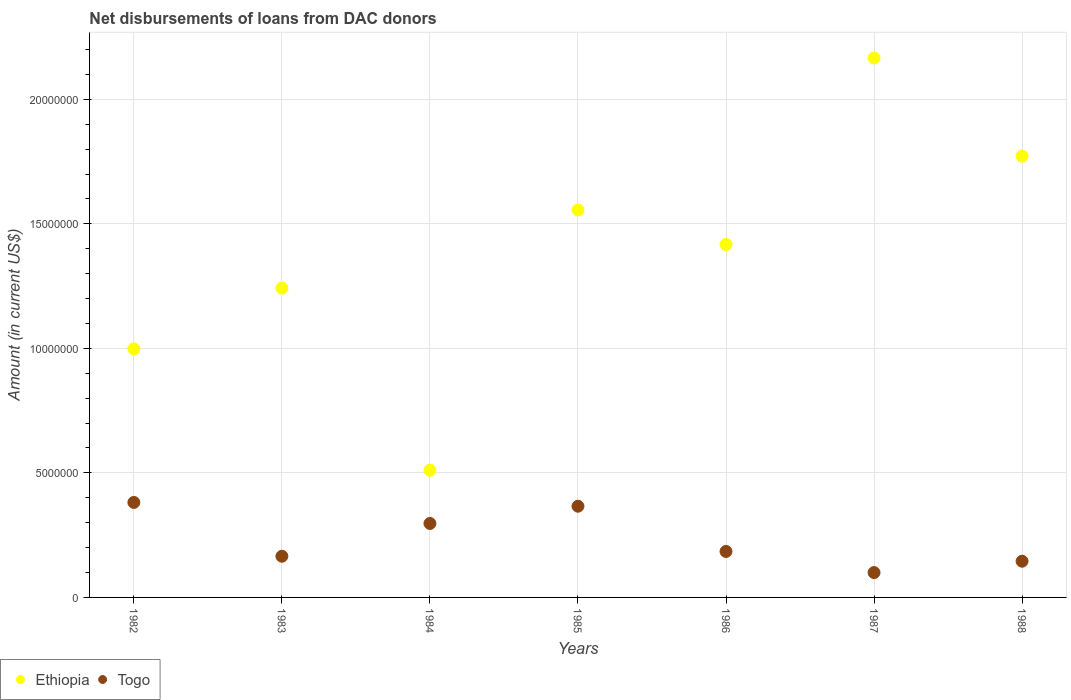Is the number of dotlines equal to the number of legend labels?
Offer a very short reply. Yes. What is the amount of loans disbursed in Ethiopia in 1987?
Keep it short and to the point. 2.17e+07. Across all years, what is the maximum amount of loans disbursed in Ethiopia?
Provide a succinct answer. 2.17e+07. Across all years, what is the minimum amount of loans disbursed in Togo?
Ensure brevity in your answer.  9.98e+05. In which year was the amount of loans disbursed in Togo maximum?
Ensure brevity in your answer.  1982. What is the total amount of loans disbursed in Togo in the graph?
Keep it short and to the point. 1.64e+07. What is the difference between the amount of loans disbursed in Togo in 1985 and that in 1988?
Give a very brief answer. 2.21e+06. What is the difference between the amount of loans disbursed in Ethiopia in 1985 and the amount of loans disbursed in Togo in 1982?
Make the answer very short. 1.17e+07. What is the average amount of loans disbursed in Ethiopia per year?
Give a very brief answer. 1.38e+07. In the year 1988, what is the difference between the amount of loans disbursed in Togo and amount of loans disbursed in Ethiopia?
Keep it short and to the point. -1.63e+07. What is the ratio of the amount of loans disbursed in Togo in 1983 to that in 1985?
Your answer should be compact. 0.45. Is the amount of loans disbursed in Togo in 1985 less than that in 1986?
Your answer should be very brief. No. Is the difference between the amount of loans disbursed in Togo in 1982 and 1984 greater than the difference between the amount of loans disbursed in Ethiopia in 1982 and 1984?
Your answer should be very brief. No. What is the difference between the highest and the second highest amount of loans disbursed in Togo?
Your answer should be very brief. 1.52e+05. What is the difference between the highest and the lowest amount of loans disbursed in Togo?
Offer a very short reply. 2.82e+06. In how many years, is the amount of loans disbursed in Togo greater than the average amount of loans disbursed in Togo taken over all years?
Your response must be concise. 3. Does the amount of loans disbursed in Togo monotonically increase over the years?
Your answer should be compact. No. Is the amount of loans disbursed in Ethiopia strictly greater than the amount of loans disbursed in Togo over the years?
Make the answer very short. Yes. Is the amount of loans disbursed in Togo strictly less than the amount of loans disbursed in Ethiopia over the years?
Ensure brevity in your answer.  Yes. How many dotlines are there?
Your answer should be very brief. 2. What is the difference between two consecutive major ticks on the Y-axis?
Keep it short and to the point. 5.00e+06. Are the values on the major ticks of Y-axis written in scientific E-notation?
Provide a succinct answer. No. Does the graph contain grids?
Provide a short and direct response. Yes. Where does the legend appear in the graph?
Your answer should be compact. Bottom left. How many legend labels are there?
Your response must be concise. 2. How are the legend labels stacked?
Offer a very short reply. Horizontal. What is the title of the graph?
Make the answer very short. Net disbursements of loans from DAC donors. What is the Amount (in current US$) of Ethiopia in 1982?
Your response must be concise. 9.98e+06. What is the Amount (in current US$) in Togo in 1982?
Your response must be concise. 3.81e+06. What is the Amount (in current US$) of Ethiopia in 1983?
Keep it short and to the point. 1.24e+07. What is the Amount (in current US$) of Togo in 1983?
Give a very brief answer. 1.65e+06. What is the Amount (in current US$) in Ethiopia in 1984?
Provide a short and direct response. 5.11e+06. What is the Amount (in current US$) of Togo in 1984?
Your answer should be compact. 2.97e+06. What is the Amount (in current US$) in Ethiopia in 1985?
Your response must be concise. 1.56e+07. What is the Amount (in current US$) of Togo in 1985?
Offer a very short reply. 3.66e+06. What is the Amount (in current US$) in Ethiopia in 1986?
Keep it short and to the point. 1.42e+07. What is the Amount (in current US$) in Togo in 1986?
Offer a very short reply. 1.85e+06. What is the Amount (in current US$) in Ethiopia in 1987?
Provide a short and direct response. 2.17e+07. What is the Amount (in current US$) in Togo in 1987?
Offer a very short reply. 9.98e+05. What is the Amount (in current US$) of Ethiopia in 1988?
Your answer should be very brief. 1.77e+07. What is the Amount (in current US$) in Togo in 1988?
Provide a succinct answer. 1.45e+06. Across all years, what is the maximum Amount (in current US$) in Ethiopia?
Offer a very short reply. 2.17e+07. Across all years, what is the maximum Amount (in current US$) of Togo?
Your response must be concise. 3.81e+06. Across all years, what is the minimum Amount (in current US$) of Ethiopia?
Keep it short and to the point. 5.11e+06. Across all years, what is the minimum Amount (in current US$) in Togo?
Offer a very short reply. 9.98e+05. What is the total Amount (in current US$) in Ethiopia in the graph?
Ensure brevity in your answer.  9.66e+07. What is the total Amount (in current US$) in Togo in the graph?
Keep it short and to the point. 1.64e+07. What is the difference between the Amount (in current US$) of Ethiopia in 1982 and that in 1983?
Your response must be concise. -2.44e+06. What is the difference between the Amount (in current US$) in Togo in 1982 and that in 1983?
Give a very brief answer. 2.16e+06. What is the difference between the Amount (in current US$) in Ethiopia in 1982 and that in 1984?
Provide a short and direct response. 4.87e+06. What is the difference between the Amount (in current US$) in Togo in 1982 and that in 1984?
Make the answer very short. 8.44e+05. What is the difference between the Amount (in current US$) of Ethiopia in 1982 and that in 1985?
Provide a short and direct response. -5.58e+06. What is the difference between the Amount (in current US$) in Togo in 1982 and that in 1985?
Provide a short and direct response. 1.52e+05. What is the difference between the Amount (in current US$) in Ethiopia in 1982 and that in 1986?
Keep it short and to the point. -4.19e+06. What is the difference between the Amount (in current US$) of Togo in 1982 and that in 1986?
Offer a very short reply. 1.97e+06. What is the difference between the Amount (in current US$) in Ethiopia in 1982 and that in 1987?
Give a very brief answer. -1.17e+07. What is the difference between the Amount (in current US$) in Togo in 1982 and that in 1987?
Offer a very short reply. 2.82e+06. What is the difference between the Amount (in current US$) of Ethiopia in 1982 and that in 1988?
Provide a short and direct response. -7.74e+06. What is the difference between the Amount (in current US$) of Togo in 1982 and that in 1988?
Keep it short and to the point. 2.36e+06. What is the difference between the Amount (in current US$) in Ethiopia in 1983 and that in 1984?
Ensure brevity in your answer.  7.31e+06. What is the difference between the Amount (in current US$) of Togo in 1983 and that in 1984?
Keep it short and to the point. -1.32e+06. What is the difference between the Amount (in current US$) of Ethiopia in 1983 and that in 1985?
Give a very brief answer. -3.14e+06. What is the difference between the Amount (in current US$) of Togo in 1983 and that in 1985?
Offer a very short reply. -2.01e+06. What is the difference between the Amount (in current US$) in Ethiopia in 1983 and that in 1986?
Provide a succinct answer. -1.75e+06. What is the difference between the Amount (in current US$) of Togo in 1983 and that in 1986?
Give a very brief answer. -1.93e+05. What is the difference between the Amount (in current US$) in Ethiopia in 1983 and that in 1987?
Provide a short and direct response. -9.24e+06. What is the difference between the Amount (in current US$) of Togo in 1983 and that in 1987?
Your response must be concise. 6.55e+05. What is the difference between the Amount (in current US$) of Ethiopia in 1983 and that in 1988?
Provide a short and direct response. -5.30e+06. What is the difference between the Amount (in current US$) of Togo in 1983 and that in 1988?
Offer a very short reply. 1.99e+05. What is the difference between the Amount (in current US$) in Ethiopia in 1984 and that in 1985?
Ensure brevity in your answer.  -1.04e+07. What is the difference between the Amount (in current US$) in Togo in 1984 and that in 1985?
Provide a short and direct response. -6.92e+05. What is the difference between the Amount (in current US$) in Ethiopia in 1984 and that in 1986?
Your response must be concise. -9.06e+06. What is the difference between the Amount (in current US$) of Togo in 1984 and that in 1986?
Ensure brevity in your answer.  1.12e+06. What is the difference between the Amount (in current US$) of Ethiopia in 1984 and that in 1987?
Keep it short and to the point. -1.66e+07. What is the difference between the Amount (in current US$) of Togo in 1984 and that in 1987?
Give a very brief answer. 1.97e+06. What is the difference between the Amount (in current US$) of Ethiopia in 1984 and that in 1988?
Offer a very short reply. -1.26e+07. What is the difference between the Amount (in current US$) of Togo in 1984 and that in 1988?
Your answer should be compact. 1.52e+06. What is the difference between the Amount (in current US$) in Ethiopia in 1985 and that in 1986?
Offer a terse response. 1.39e+06. What is the difference between the Amount (in current US$) of Togo in 1985 and that in 1986?
Provide a short and direct response. 1.82e+06. What is the difference between the Amount (in current US$) in Ethiopia in 1985 and that in 1987?
Keep it short and to the point. -6.10e+06. What is the difference between the Amount (in current US$) in Togo in 1985 and that in 1987?
Offer a very short reply. 2.66e+06. What is the difference between the Amount (in current US$) of Ethiopia in 1985 and that in 1988?
Offer a terse response. -2.16e+06. What is the difference between the Amount (in current US$) of Togo in 1985 and that in 1988?
Keep it short and to the point. 2.21e+06. What is the difference between the Amount (in current US$) of Ethiopia in 1986 and that in 1987?
Make the answer very short. -7.49e+06. What is the difference between the Amount (in current US$) in Togo in 1986 and that in 1987?
Make the answer very short. 8.48e+05. What is the difference between the Amount (in current US$) of Ethiopia in 1986 and that in 1988?
Give a very brief answer. -3.55e+06. What is the difference between the Amount (in current US$) in Togo in 1986 and that in 1988?
Your answer should be very brief. 3.92e+05. What is the difference between the Amount (in current US$) of Ethiopia in 1987 and that in 1988?
Provide a short and direct response. 3.94e+06. What is the difference between the Amount (in current US$) in Togo in 1987 and that in 1988?
Offer a terse response. -4.56e+05. What is the difference between the Amount (in current US$) of Ethiopia in 1982 and the Amount (in current US$) of Togo in 1983?
Your answer should be compact. 8.33e+06. What is the difference between the Amount (in current US$) of Ethiopia in 1982 and the Amount (in current US$) of Togo in 1984?
Offer a terse response. 7.01e+06. What is the difference between the Amount (in current US$) of Ethiopia in 1982 and the Amount (in current US$) of Togo in 1985?
Provide a succinct answer. 6.32e+06. What is the difference between the Amount (in current US$) of Ethiopia in 1982 and the Amount (in current US$) of Togo in 1986?
Offer a very short reply. 8.13e+06. What is the difference between the Amount (in current US$) of Ethiopia in 1982 and the Amount (in current US$) of Togo in 1987?
Your response must be concise. 8.98e+06. What is the difference between the Amount (in current US$) of Ethiopia in 1982 and the Amount (in current US$) of Togo in 1988?
Keep it short and to the point. 8.52e+06. What is the difference between the Amount (in current US$) of Ethiopia in 1983 and the Amount (in current US$) of Togo in 1984?
Provide a succinct answer. 9.45e+06. What is the difference between the Amount (in current US$) of Ethiopia in 1983 and the Amount (in current US$) of Togo in 1985?
Make the answer very short. 8.76e+06. What is the difference between the Amount (in current US$) in Ethiopia in 1983 and the Amount (in current US$) in Togo in 1986?
Ensure brevity in your answer.  1.06e+07. What is the difference between the Amount (in current US$) in Ethiopia in 1983 and the Amount (in current US$) in Togo in 1987?
Provide a short and direct response. 1.14e+07. What is the difference between the Amount (in current US$) in Ethiopia in 1983 and the Amount (in current US$) in Togo in 1988?
Ensure brevity in your answer.  1.10e+07. What is the difference between the Amount (in current US$) of Ethiopia in 1984 and the Amount (in current US$) of Togo in 1985?
Keep it short and to the point. 1.45e+06. What is the difference between the Amount (in current US$) in Ethiopia in 1984 and the Amount (in current US$) in Togo in 1986?
Your answer should be compact. 3.26e+06. What is the difference between the Amount (in current US$) of Ethiopia in 1984 and the Amount (in current US$) of Togo in 1987?
Provide a succinct answer. 4.11e+06. What is the difference between the Amount (in current US$) of Ethiopia in 1984 and the Amount (in current US$) of Togo in 1988?
Provide a succinct answer. 3.66e+06. What is the difference between the Amount (in current US$) of Ethiopia in 1985 and the Amount (in current US$) of Togo in 1986?
Ensure brevity in your answer.  1.37e+07. What is the difference between the Amount (in current US$) of Ethiopia in 1985 and the Amount (in current US$) of Togo in 1987?
Provide a succinct answer. 1.46e+07. What is the difference between the Amount (in current US$) in Ethiopia in 1985 and the Amount (in current US$) in Togo in 1988?
Ensure brevity in your answer.  1.41e+07. What is the difference between the Amount (in current US$) of Ethiopia in 1986 and the Amount (in current US$) of Togo in 1987?
Your response must be concise. 1.32e+07. What is the difference between the Amount (in current US$) of Ethiopia in 1986 and the Amount (in current US$) of Togo in 1988?
Your answer should be very brief. 1.27e+07. What is the difference between the Amount (in current US$) in Ethiopia in 1987 and the Amount (in current US$) in Togo in 1988?
Your answer should be compact. 2.02e+07. What is the average Amount (in current US$) in Ethiopia per year?
Keep it short and to the point. 1.38e+07. What is the average Amount (in current US$) of Togo per year?
Provide a succinct answer. 2.34e+06. In the year 1982, what is the difference between the Amount (in current US$) of Ethiopia and Amount (in current US$) of Togo?
Make the answer very short. 6.16e+06. In the year 1983, what is the difference between the Amount (in current US$) of Ethiopia and Amount (in current US$) of Togo?
Provide a succinct answer. 1.08e+07. In the year 1984, what is the difference between the Amount (in current US$) in Ethiopia and Amount (in current US$) in Togo?
Offer a terse response. 2.14e+06. In the year 1985, what is the difference between the Amount (in current US$) of Ethiopia and Amount (in current US$) of Togo?
Your answer should be compact. 1.19e+07. In the year 1986, what is the difference between the Amount (in current US$) in Ethiopia and Amount (in current US$) in Togo?
Your answer should be very brief. 1.23e+07. In the year 1987, what is the difference between the Amount (in current US$) of Ethiopia and Amount (in current US$) of Togo?
Provide a succinct answer. 2.07e+07. In the year 1988, what is the difference between the Amount (in current US$) of Ethiopia and Amount (in current US$) of Togo?
Ensure brevity in your answer.  1.63e+07. What is the ratio of the Amount (in current US$) in Ethiopia in 1982 to that in 1983?
Your answer should be compact. 0.8. What is the ratio of the Amount (in current US$) in Togo in 1982 to that in 1983?
Provide a short and direct response. 2.31. What is the ratio of the Amount (in current US$) of Ethiopia in 1982 to that in 1984?
Give a very brief answer. 1.95. What is the ratio of the Amount (in current US$) in Togo in 1982 to that in 1984?
Offer a terse response. 1.28. What is the ratio of the Amount (in current US$) of Ethiopia in 1982 to that in 1985?
Provide a short and direct response. 0.64. What is the ratio of the Amount (in current US$) in Togo in 1982 to that in 1985?
Ensure brevity in your answer.  1.04. What is the ratio of the Amount (in current US$) in Ethiopia in 1982 to that in 1986?
Your answer should be compact. 0.7. What is the ratio of the Amount (in current US$) in Togo in 1982 to that in 1986?
Make the answer very short. 2.07. What is the ratio of the Amount (in current US$) in Ethiopia in 1982 to that in 1987?
Your answer should be very brief. 0.46. What is the ratio of the Amount (in current US$) in Togo in 1982 to that in 1987?
Your response must be concise. 3.82. What is the ratio of the Amount (in current US$) of Ethiopia in 1982 to that in 1988?
Provide a short and direct response. 0.56. What is the ratio of the Amount (in current US$) of Togo in 1982 to that in 1988?
Provide a short and direct response. 2.62. What is the ratio of the Amount (in current US$) in Ethiopia in 1983 to that in 1984?
Offer a terse response. 2.43. What is the ratio of the Amount (in current US$) in Togo in 1983 to that in 1984?
Provide a short and direct response. 0.56. What is the ratio of the Amount (in current US$) of Ethiopia in 1983 to that in 1985?
Ensure brevity in your answer.  0.8. What is the ratio of the Amount (in current US$) in Togo in 1983 to that in 1985?
Your answer should be very brief. 0.45. What is the ratio of the Amount (in current US$) of Ethiopia in 1983 to that in 1986?
Provide a succinct answer. 0.88. What is the ratio of the Amount (in current US$) in Togo in 1983 to that in 1986?
Provide a short and direct response. 0.9. What is the ratio of the Amount (in current US$) in Ethiopia in 1983 to that in 1987?
Give a very brief answer. 0.57. What is the ratio of the Amount (in current US$) in Togo in 1983 to that in 1987?
Offer a very short reply. 1.66. What is the ratio of the Amount (in current US$) of Ethiopia in 1983 to that in 1988?
Offer a terse response. 0.7. What is the ratio of the Amount (in current US$) in Togo in 1983 to that in 1988?
Provide a short and direct response. 1.14. What is the ratio of the Amount (in current US$) of Ethiopia in 1984 to that in 1985?
Ensure brevity in your answer.  0.33. What is the ratio of the Amount (in current US$) of Togo in 1984 to that in 1985?
Ensure brevity in your answer.  0.81. What is the ratio of the Amount (in current US$) of Ethiopia in 1984 to that in 1986?
Offer a terse response. 0.36. What is the ratio of the Amount (in current US$) in Togo in 1984 to that in 1986?
Keep it short and to the point. 1.61. What is the ratio of the Amount (in current US$) of Ethiopia in 1984 to that in 1987?
Offer a terse response. 0.24. What is the ratio of the Amount (in current US$) of Togo in 1984 to that in 1987?
Your answer should be very brief. 2.98. What is the ratio of the Amount (in current US$) in Ethiopia in 1984 to that in 1988?
Your answer should be compact. 0.29. What is the ratio of the Amount (in current US$) in Togo in 1984 to that in 1988?
Make the answer very short. 2.04. What is the ratio of the Amount (in current US$) in Ethiopia in 1985 to that in 1986?
Offer a very short reply. 1.1. What is the ratio of the Amount (in current US$) of Togo in 1985 to that in 1986?
Your answer should be compact. 1.98. What is the ratio of the Amount (in current US$) in Ethiopia in 1985 to that in 1987?
Your response must be concise. 0.72. What is the ratio of the Amount (in current US$) of Togo in 1985 to that in 1987?
Provide a short and direct response. 3.67. What is the ratio of the Amount (in current US$) of Ethiopia in 1985 to that in 1988?
Provide a short and direct response. 0.88. What is the ratio of the Amount (in current US$) in Togo in 1985 to that in 1988?
Provide a succinct answer. 2.52. What is the ratio of the Amount (in current US$) in Ethiopia in 1986 to that in 1987?
Your answer should be very brief. 0.65. What is the ratio of the Amount (in current US$) in Togo in 1986 to that in 1987?
Your answer should be very brief. 1.85. What is the ratio of the Amount (in current US$) in Ethiopia in 1986 to that in 1988?
Provide a short and direct response. 0.8. What is the ratio of the Amount (in current US$) of Togo in 1986 to that in 1988?
Make the answer very short. 1.27. What is the ratio of the Amount (in current US$) of Ethiopia in 1987 to that in 1988?
Ensure brevity in your answer.  1.22. What is the ratio of the Amount (in current US$) of Togo in 1987 to that in 1988?
Offer a very short reply. 0.69. What is the difference between the highest and the second highest Amount (in current US$) of Ethiopia?
Your response must be concise. 3.94e+06. What is the difference between the highest and the second highest Amount (in current US$) of Togo?
Keep it short and to the point. 1.52e+05. What is the difference between the highest and the lowest Amount (in current US$) of Ethiopia?
Make the answer very short. 1.66e+07. What is the difference between the highest and the lowest Amount (in current US$) in Togo?
Keep it short and to the point. 2.82e+06. 